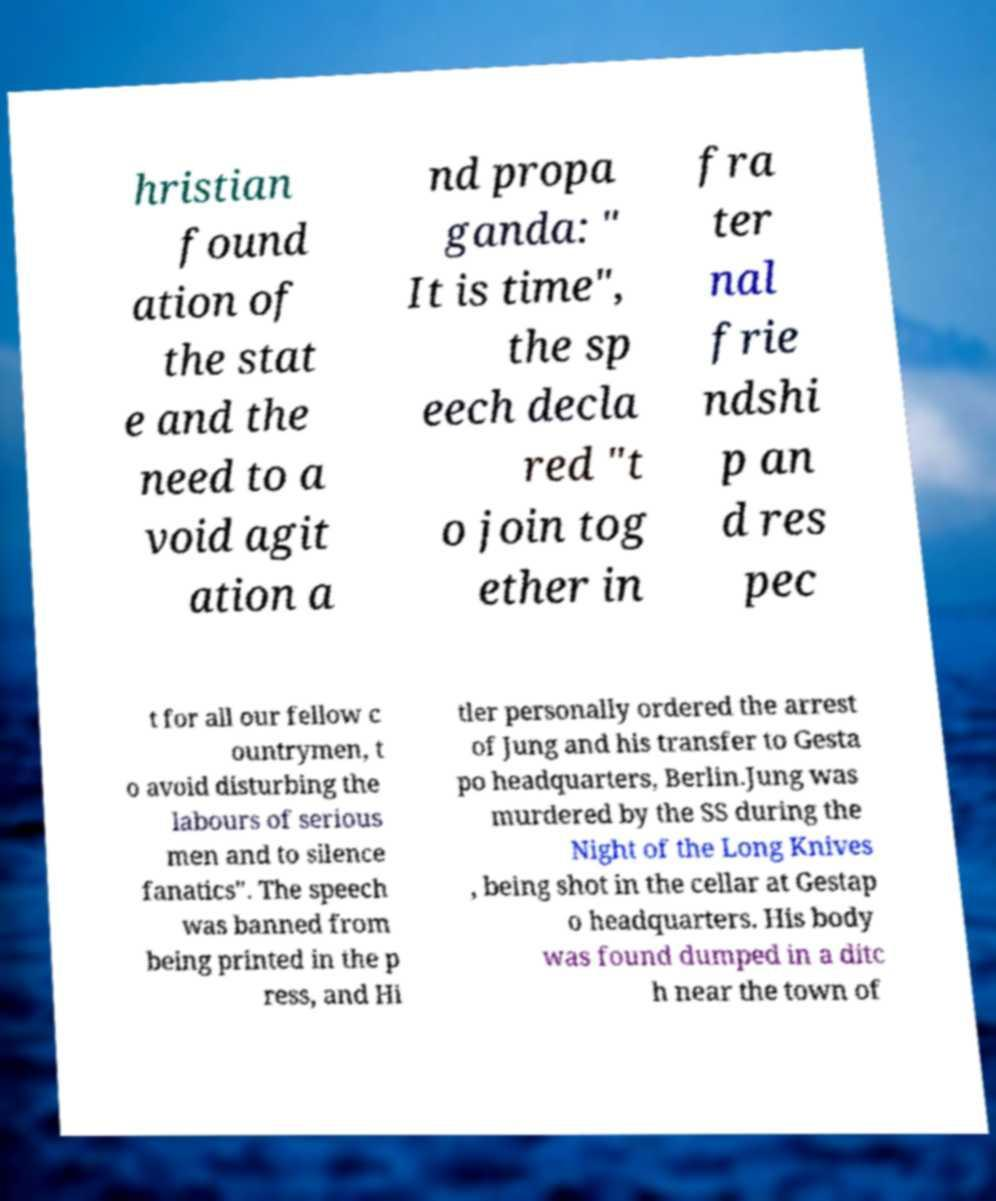What messages or text are displayed in this image? I need them in a readable, typed format. hristian found ation of the stat e and the need to a void agit ation a nd propa ganda: " It is time", the sp eech decla red "t o join tog ether in fra ter nal frie ndshi p an d res pec t for all our fellow c ountrymen, t o avoid disturbing the labours of serious men and to silence fanatics". The speech was banned from being printed in the p ress, and Hi tler personally ordered the arrest of Jung and his transfer to Gesta po headquarters, Berlin.Jung was murdered by the SS during the Night of the Long Knives , being shot in the cellar at Gestap o headquarters. His body was found dumped in a ditc h near the town of 